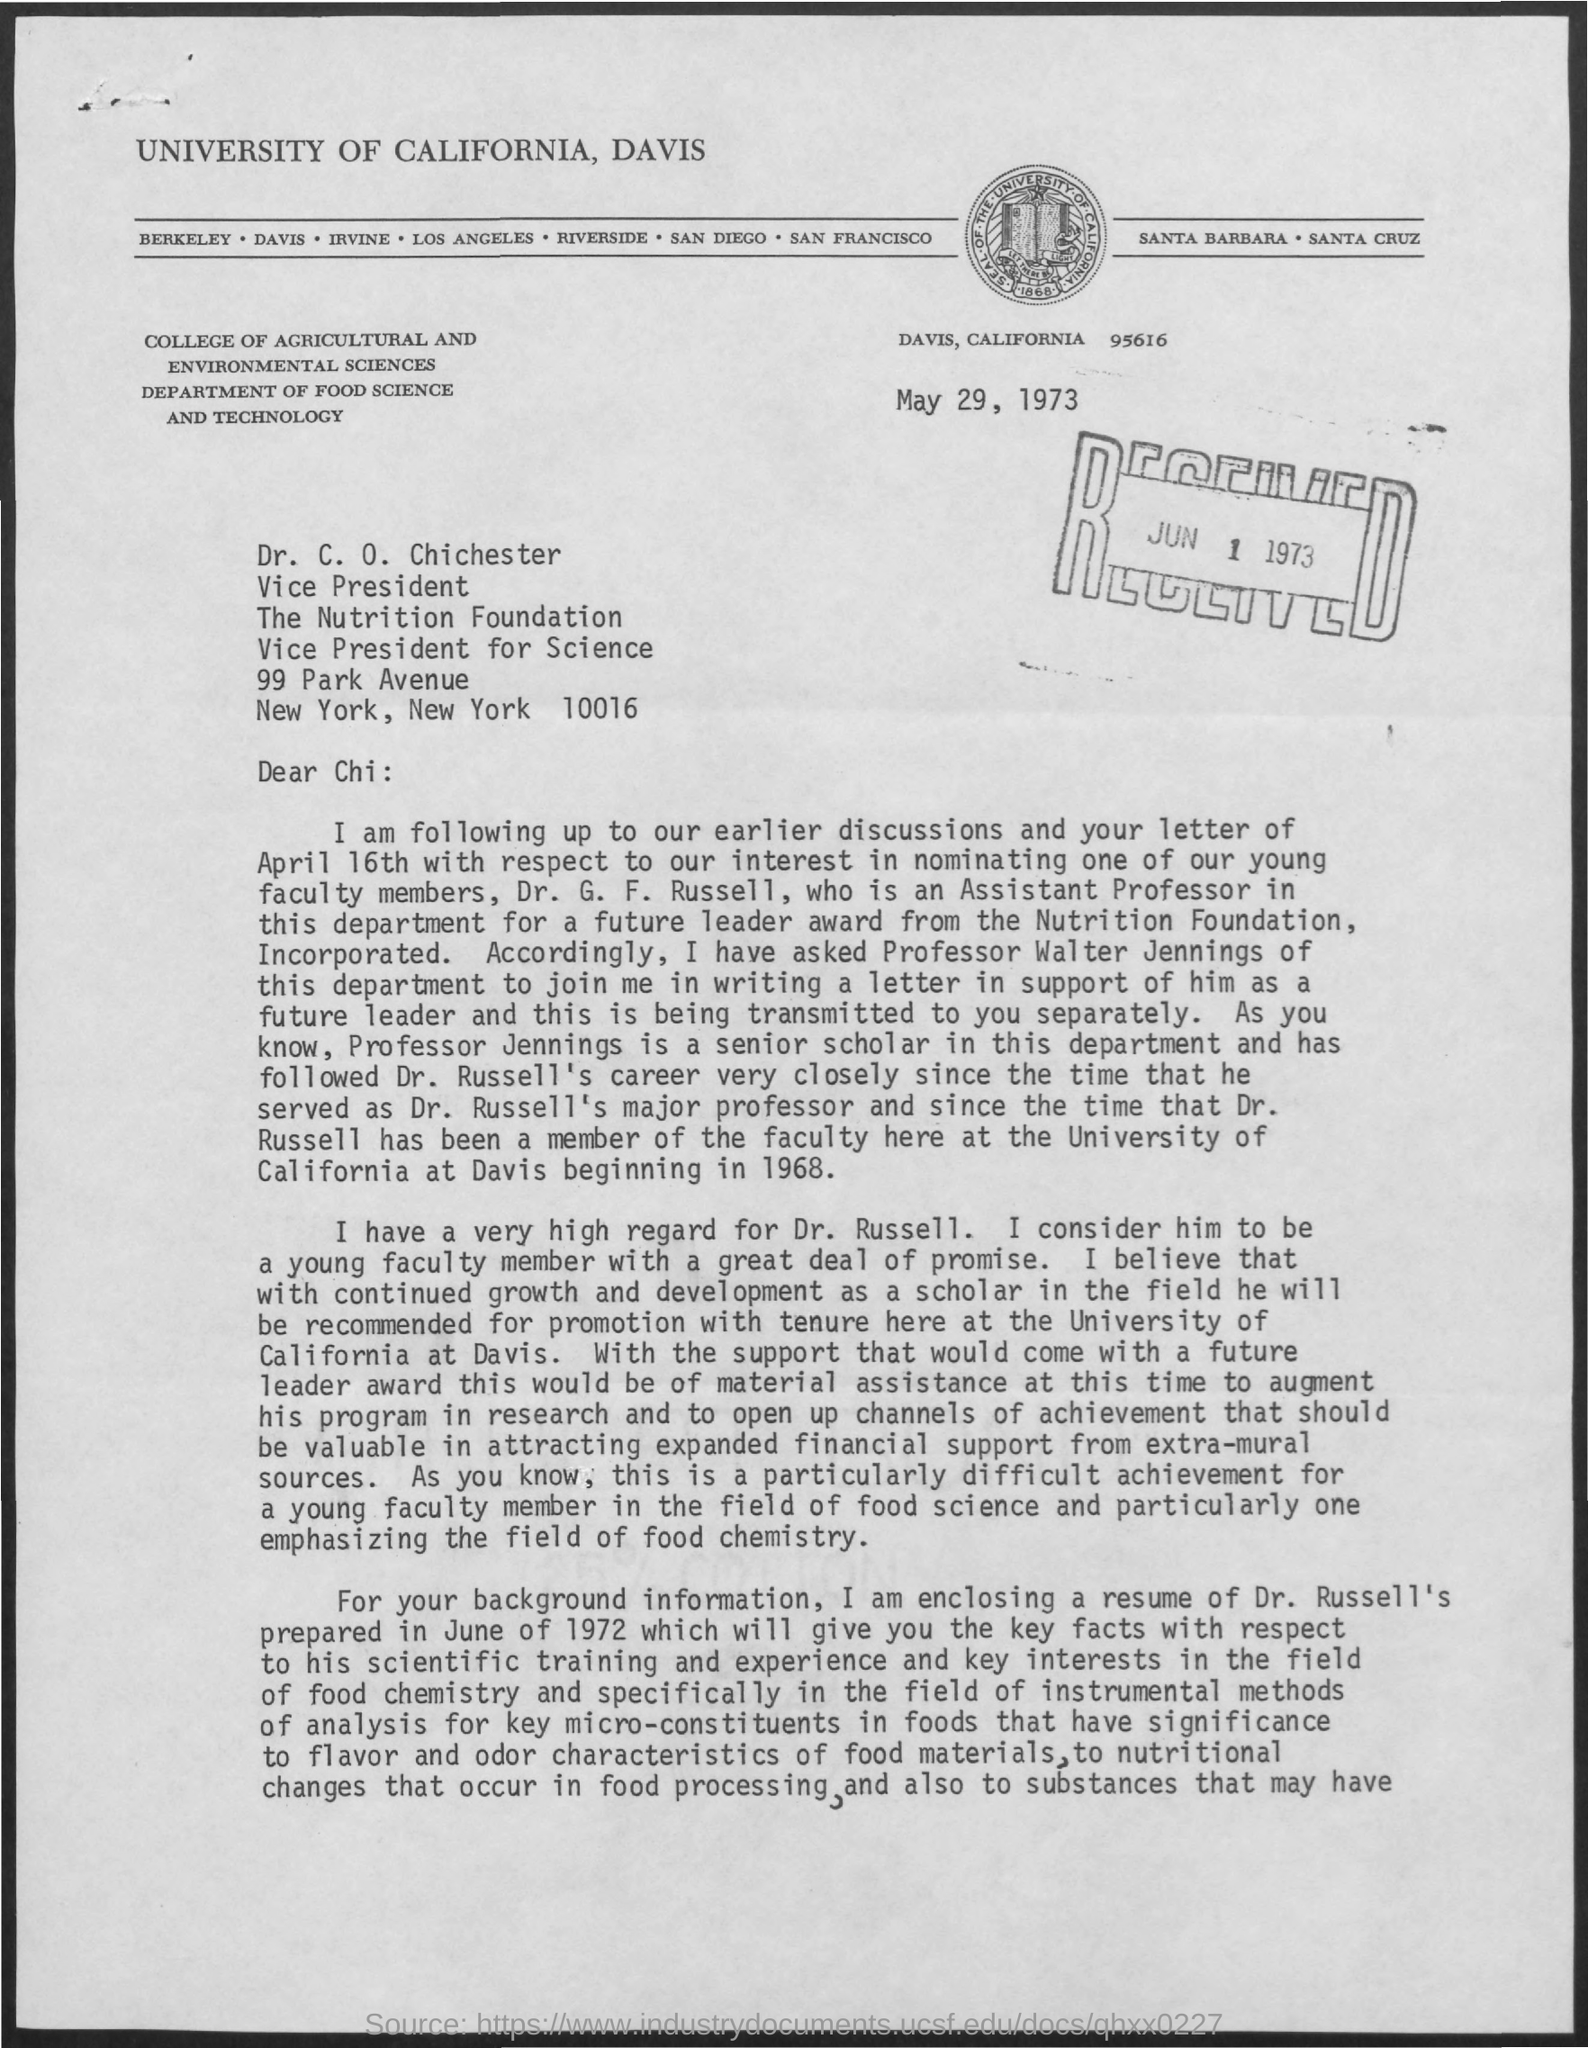Specify some key components in this picture. The college mentioned in the given letter is the College of Agricultural and Environmental Sciences. This letter was written on May 29, 1973. This letter was received on June 1, 1973. 